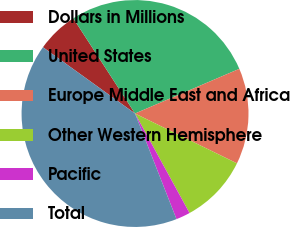Convert chart. <chart><loc_0><loc_0><loc_500><loc_500><pie_chart><fcel>Dollars in Millions<fcel>United States<fcel>Europe Middle East and Africa<fcel>Other Western Hemisphere<fcel>Pacific<fcel>Total<nl><fcel>5.91%<fcel>27.72%<fcel>13.68%<fcel>9.79%<fcel>2.02%<fcel>40.89%<nl></chart> 